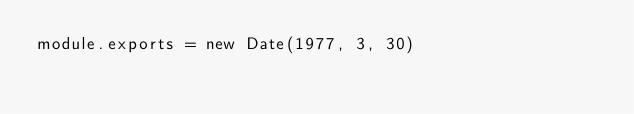<code> <loc_0><loc_0><loc_500><loc_500><_JavaScript_>module.exports = new Date(1977, 3, 30)
</code> 